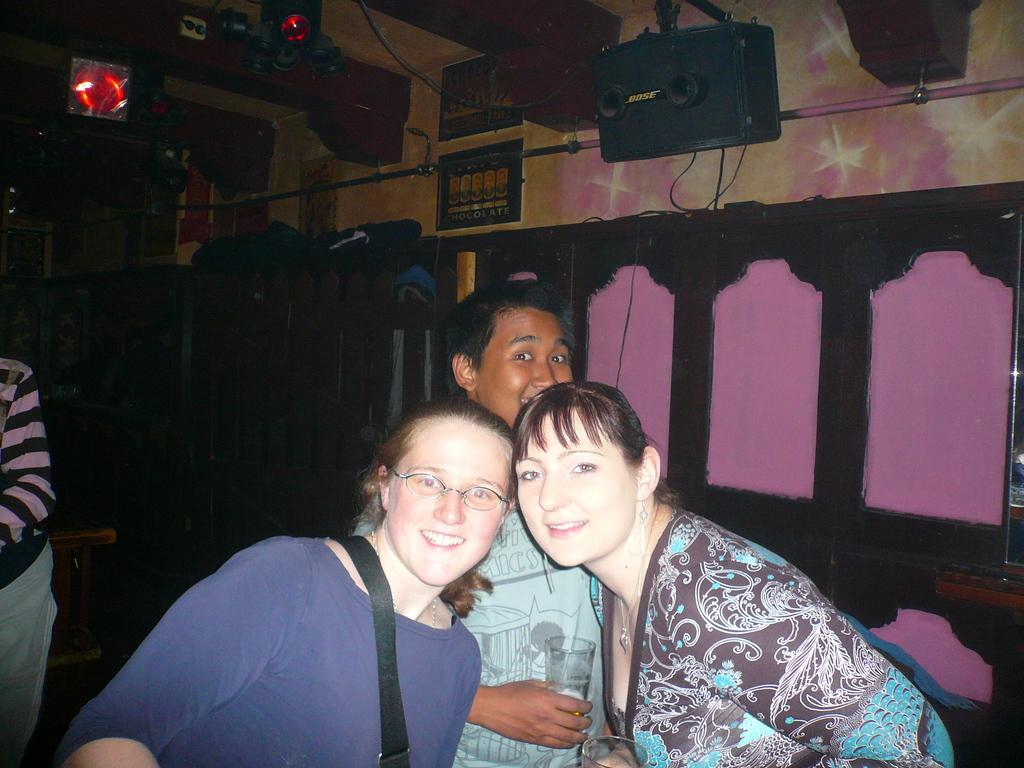How many people are in the image? There are people in the image. Can you describe the expressions of the people in the image? Two women are smiling in the image. What is the man in the image holding? A man is holding a glass in the image. What can be seen in the background of the image? There are objects attached to the wall in the background of the image. What joke did the man tell to make the women laugh in the image? There is no indication in the image that a joke was told or that the women are laughing at a joke. 